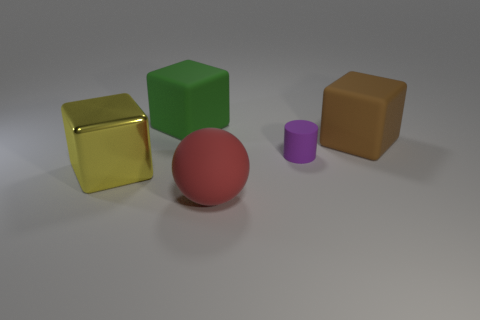Add 3 small red metallic cylinders. How many objects exist? 8 Subtract all blocks. How many objects are left? 2 Subtract 0 yellow cylinders. How many objects are left? 5 Subtract all yellow objects. Subtract all matte blocks. How many objects are left? 2 Add 2 big red matte spheres. How many big red matte spheres are left? 3 Add 1 small purple rubber cylinders. How many small purple rubber cylinders exist? 2 